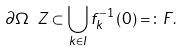<formula> <loc_0><loc_0><loc_500><loc_500>\partial \Omega \ Z \subset \bigcup _ { k \in I } f _ { k } ^ { - 1 } \left ( 0 \right ) = \colon F .</formula> 